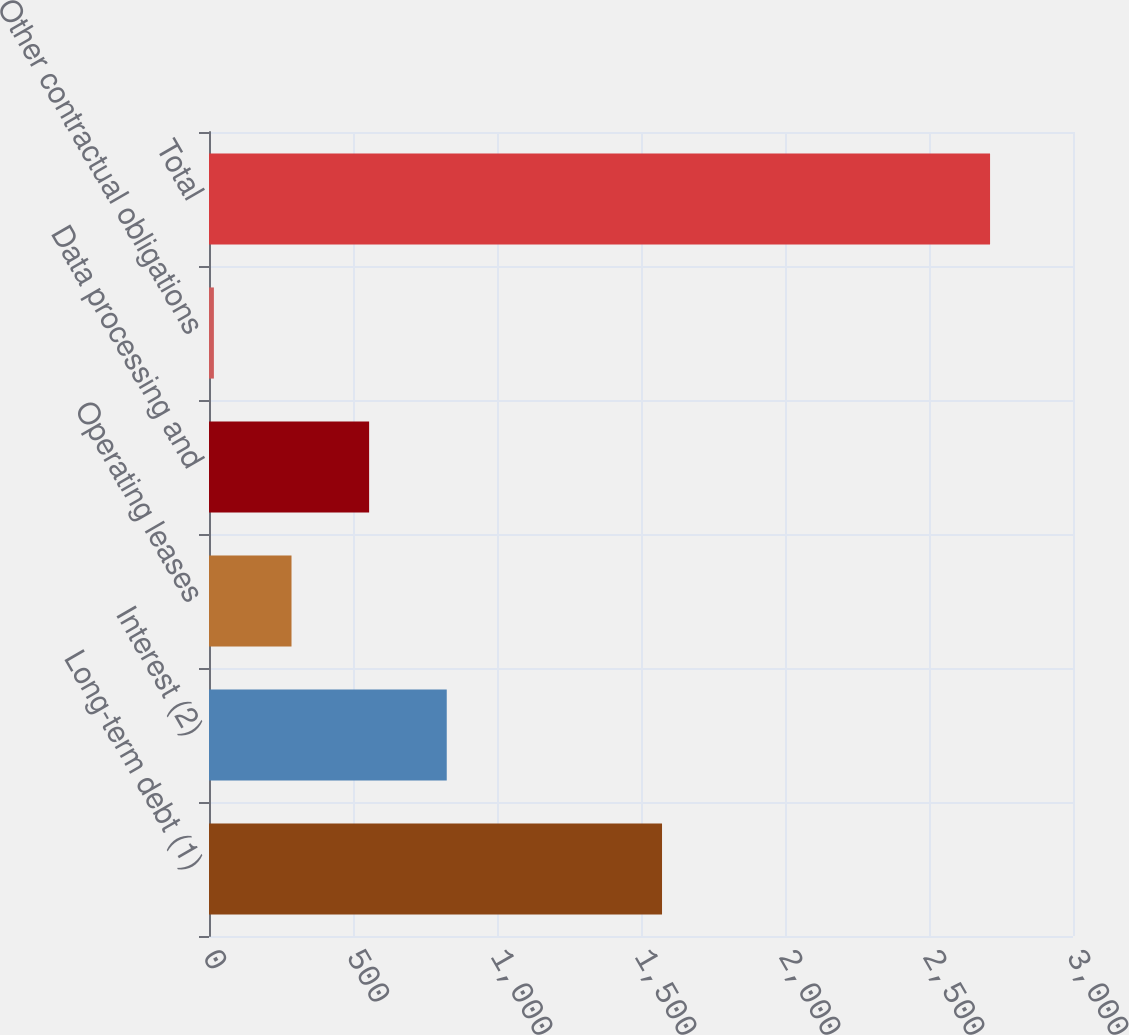Convert chart to OTSL. <chart><loc_0><loc_0><loc_500><loc_500><bar_chart><fcel>Long-term debt (1)<fcel>Interest (2)<fcel>Operating leases<fcel>Data processing and<fcel>Other contractual obligations<fcel>Total<nl><fcel>1573<fcel>825.5<fcel>286.5<fcel>556<fcel>17<fcel>2712<nl></chart> 